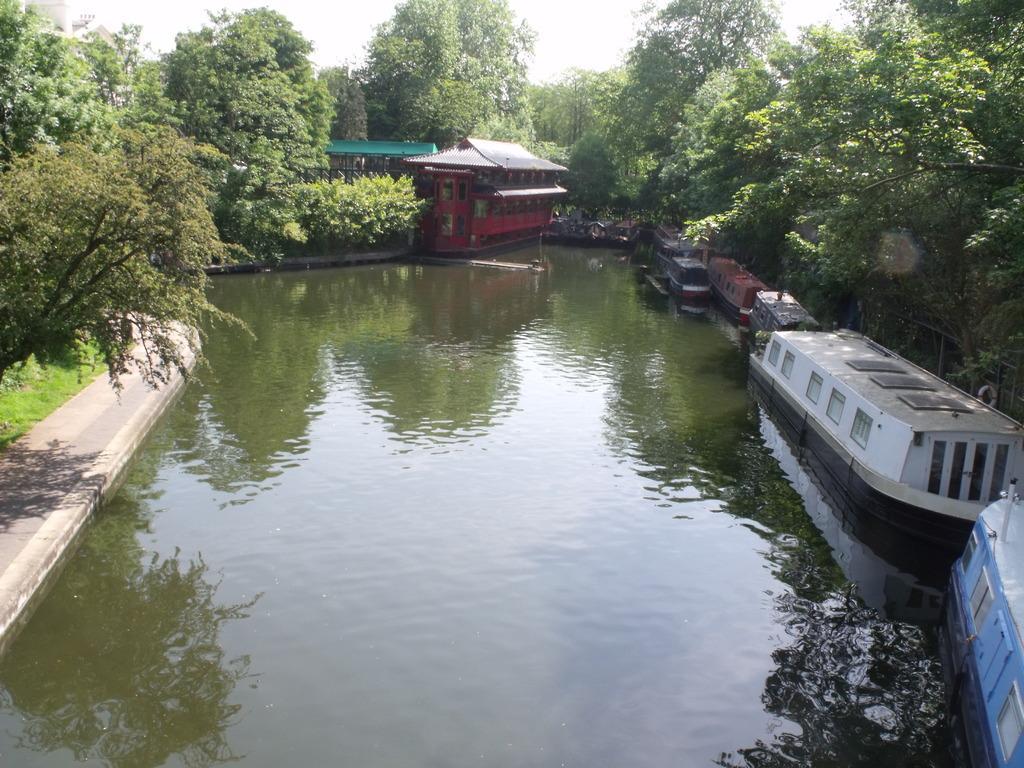Please provide a concise description of this image. In this image we can see the building and also the roof for shelter. We can also see the boats on the surface of the water. We can see the path, grass, trees and also the sky. 